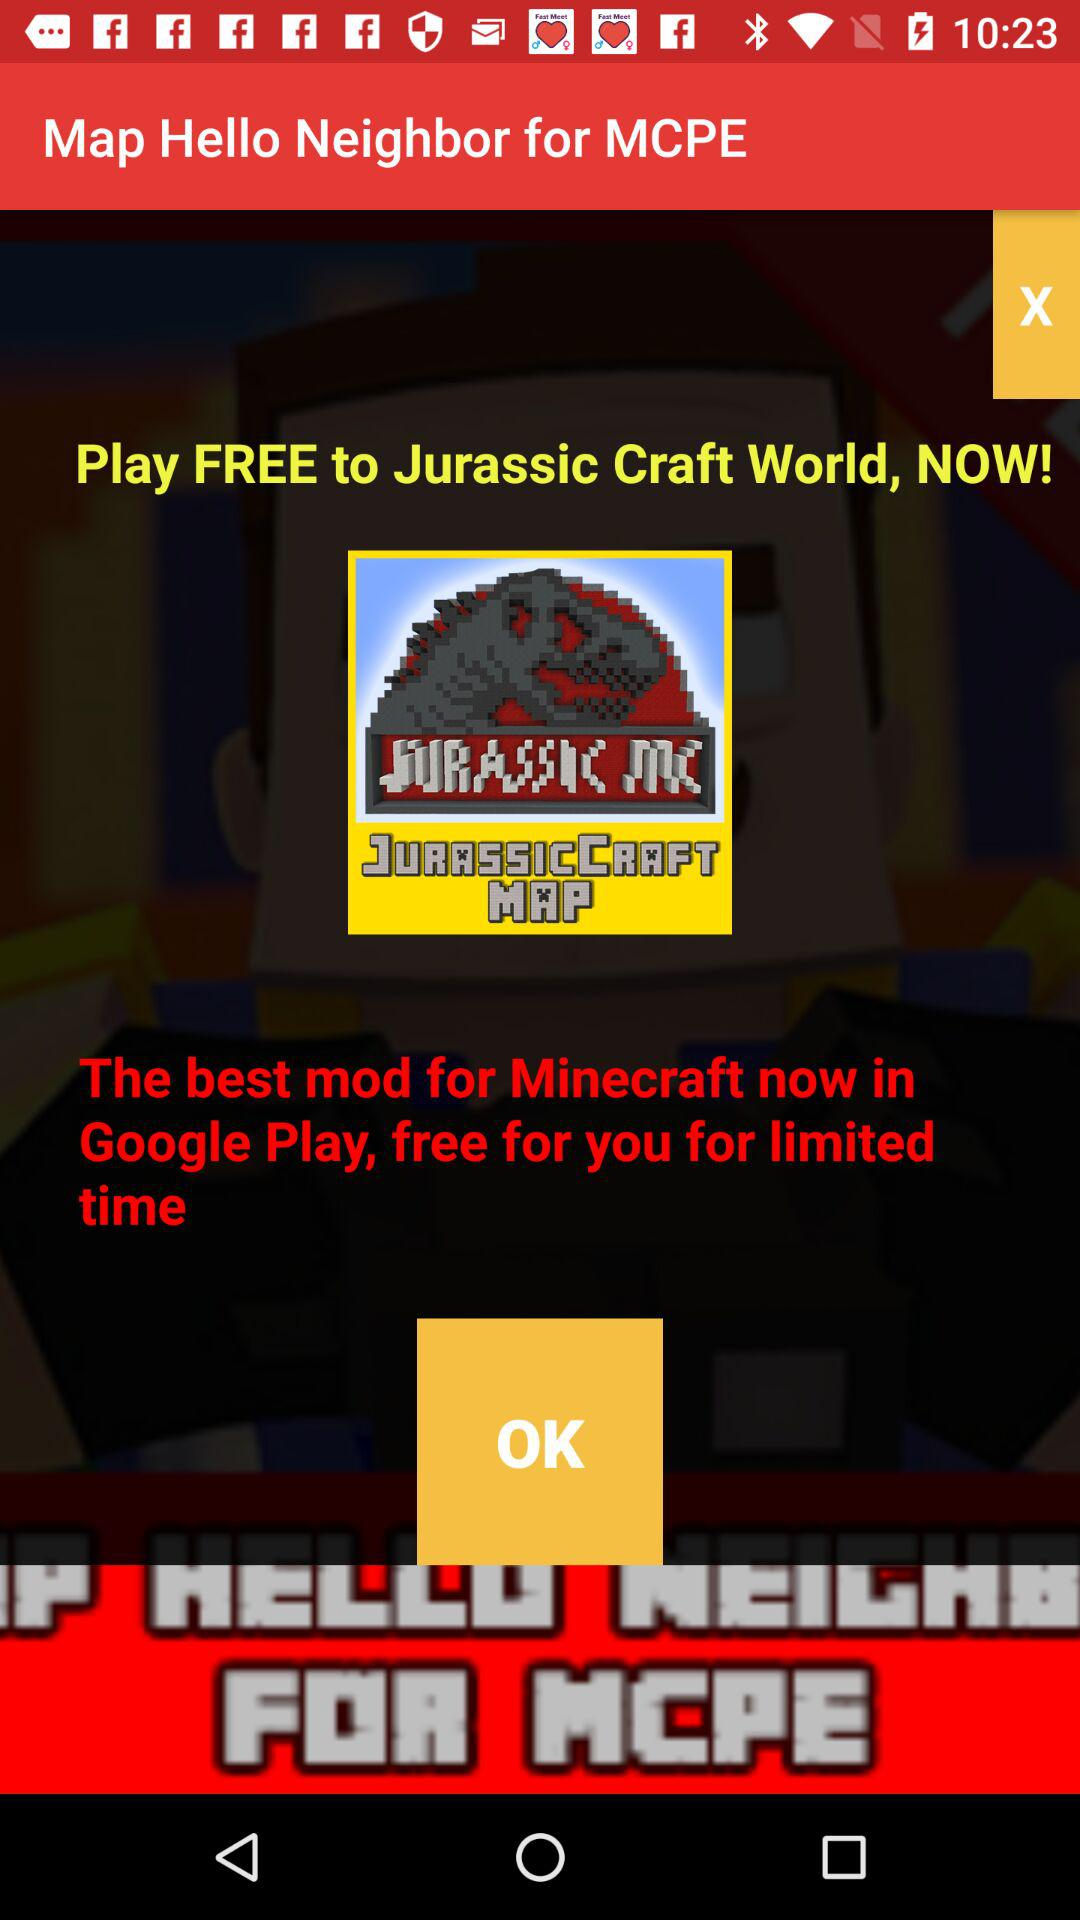How many stars does the "Jurassic Craft World" have?
When the provided information is insufficient, respond with <no answer>. <no answer> 